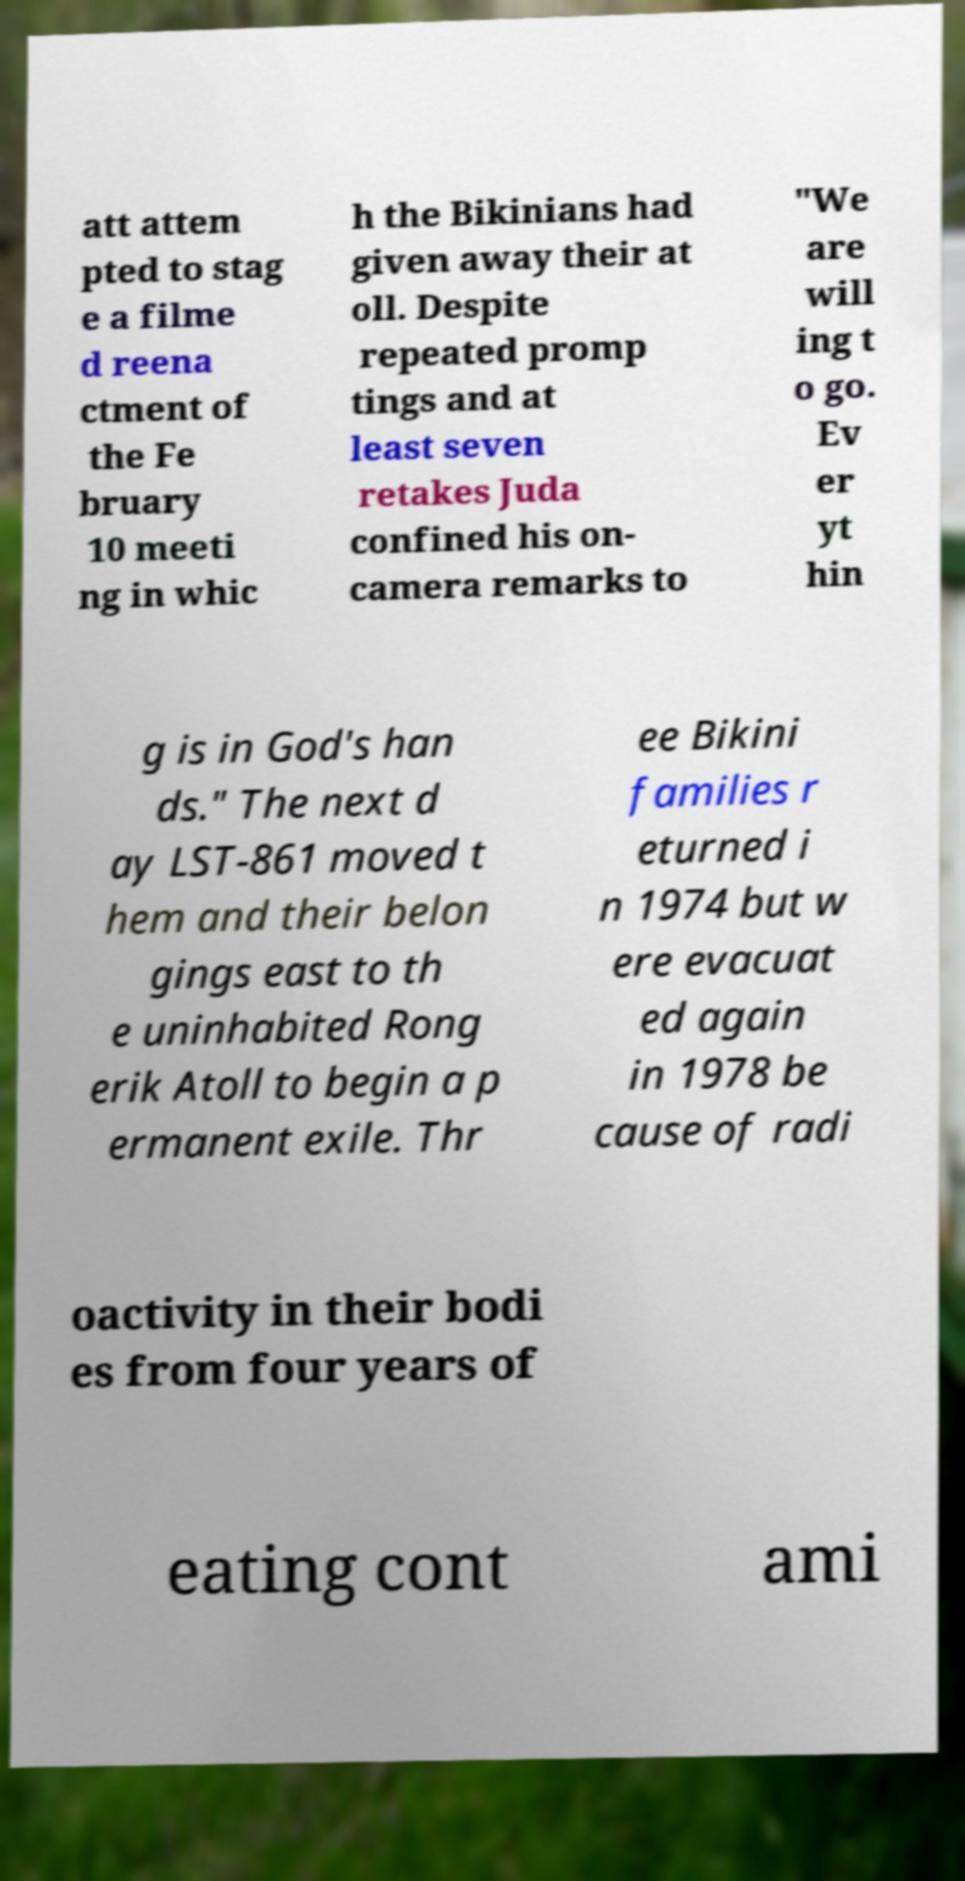Please read and relay the text visible in this image. What does it say? att attem pted to stag e a filme d reena ctment of the Fe bruary 10 meeti ng in whic h the Bikinians had given away their at oll. Despite repeated promp tings and at least seven retakes Juda confined his on- camera remarks to "We are will ing t o go. Ev er yt hin g is in God's han ds." The next d ay LST-861 moved t hem and their belon gings east to th e uninhabited Rong erik Atoll to begin a p ermanent exile. Thr ee Bikini families r eturned i n 1974 but w ere evacuat ed again in 1978 be cause of radi oactivity in their bodi es from four years of eating cont ami 